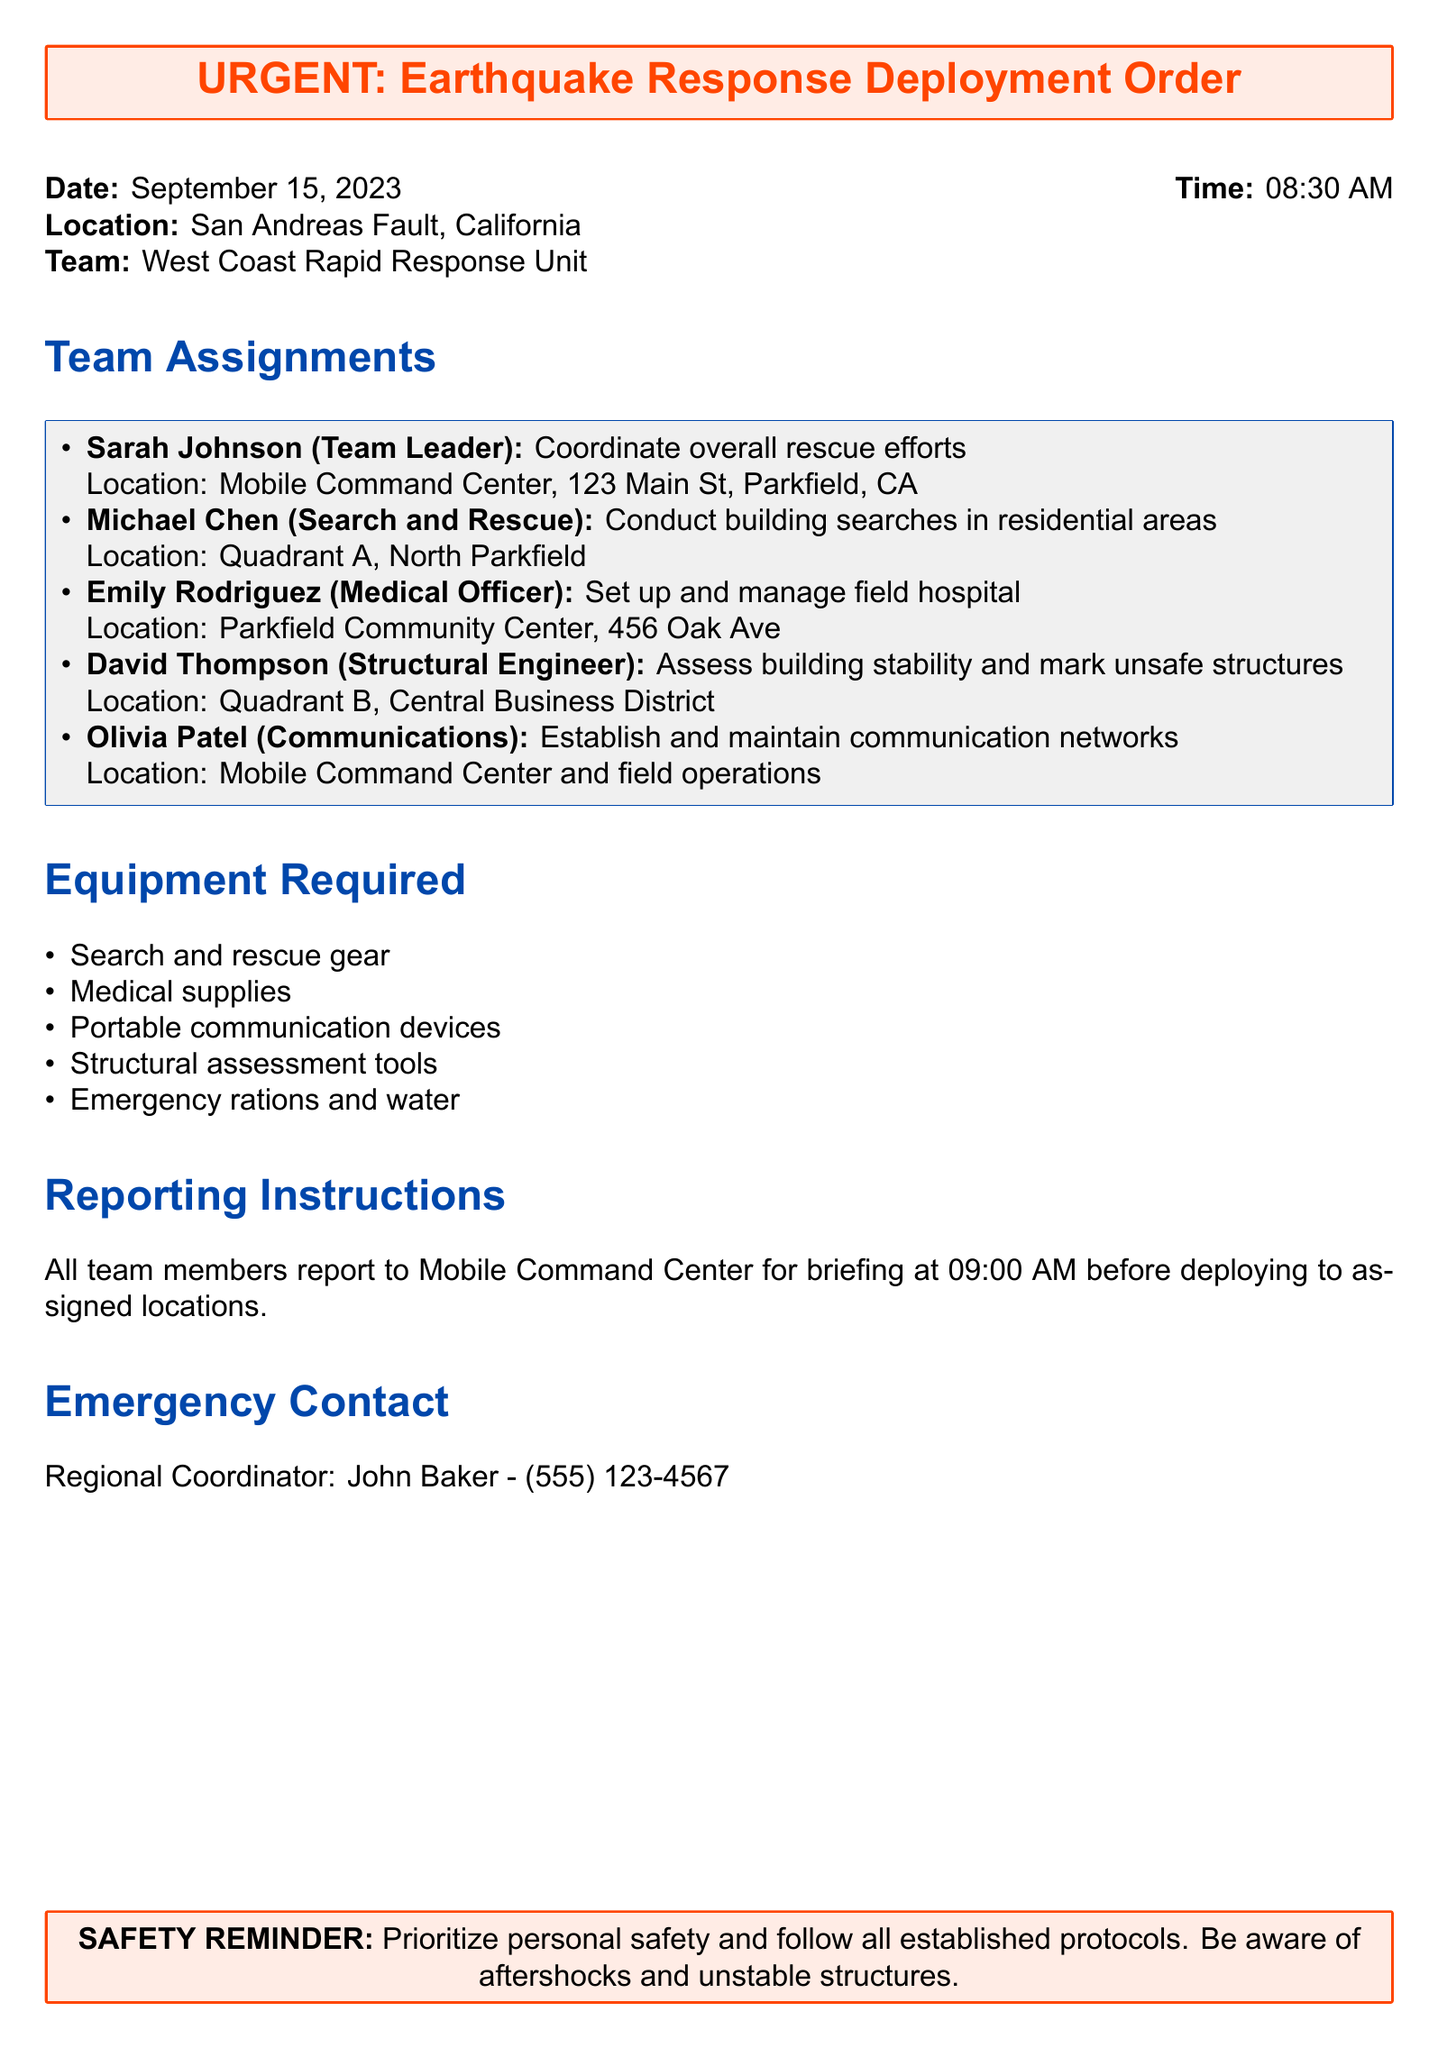What is the date of the deployment order? The date can be found in the document, showing when the deployment order was issued, which is September 15, 2023.
Answer: September 15, 2023 Who is the Team Leader? The document specifies the team assignments and identifies Sarah Johnson as the Team Leader.
Answer: Sarah Johnson What location is assigned to Michael Chen? The document lists the specific location where Michael Chen will conduct building searches, which is Quadrant A, North Parkfield.
Answer: Quadrant A, North Parkfield What time are all team members required to report for briefing? The document states the time for the briefing session before deployment, which is 09:00 AM.
Answer: 09:00 AM Who is the Regional Coordinator? The document mentions John Baker as the contact person for the team, identifying him as the Regional Coordinator.
Answer: John Baker How many different roles are specified in the team assignments? By counting the distinct roles listed in the assignments, we find there are five roles.
Answer: Five roles What equipment is required for the medical officer? The equipment section includes a list and we specifically note that medical supplies are needed for the Medical Officer.
Answer: Medical supplies What is the emergency contact number provided? The document specifies a contact number for the Regional Coordinator, which is included for emergencies, which is (555) 123-4567.
Answer: (555) 123-4567 What is stressed as a safety reminder? The last section emphasizes the importance of safety, specifically prioritizing personal safety and being aware of aftershocks and unstable structures.
Answer: Prioritize personal safety and follow all established protocols 